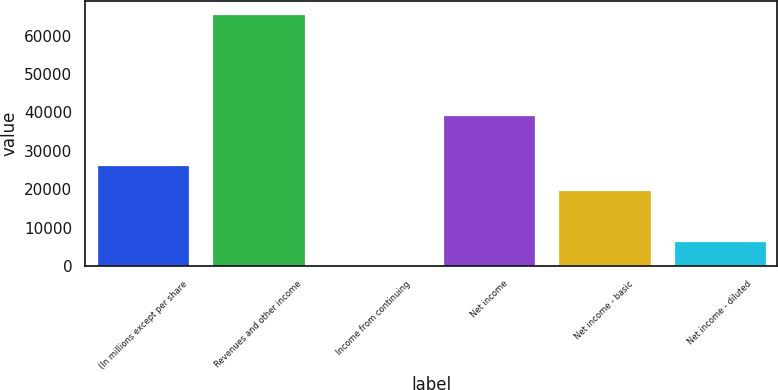Convert chart. <chart><loc_0><loc_0><loc_500><loc_500><bar_chart><fcel>(In millions except per share<fcel>Revenues and other income<fcel>Income from continuing<fcel>Net income<fcel>Net income - basic<fcel>Net income - diluted<nl><fcel>26251<fcel>65614<fcel>9.01<fcel>39372<fcel>19690.5<fcel>6569.51<nl></chart> 